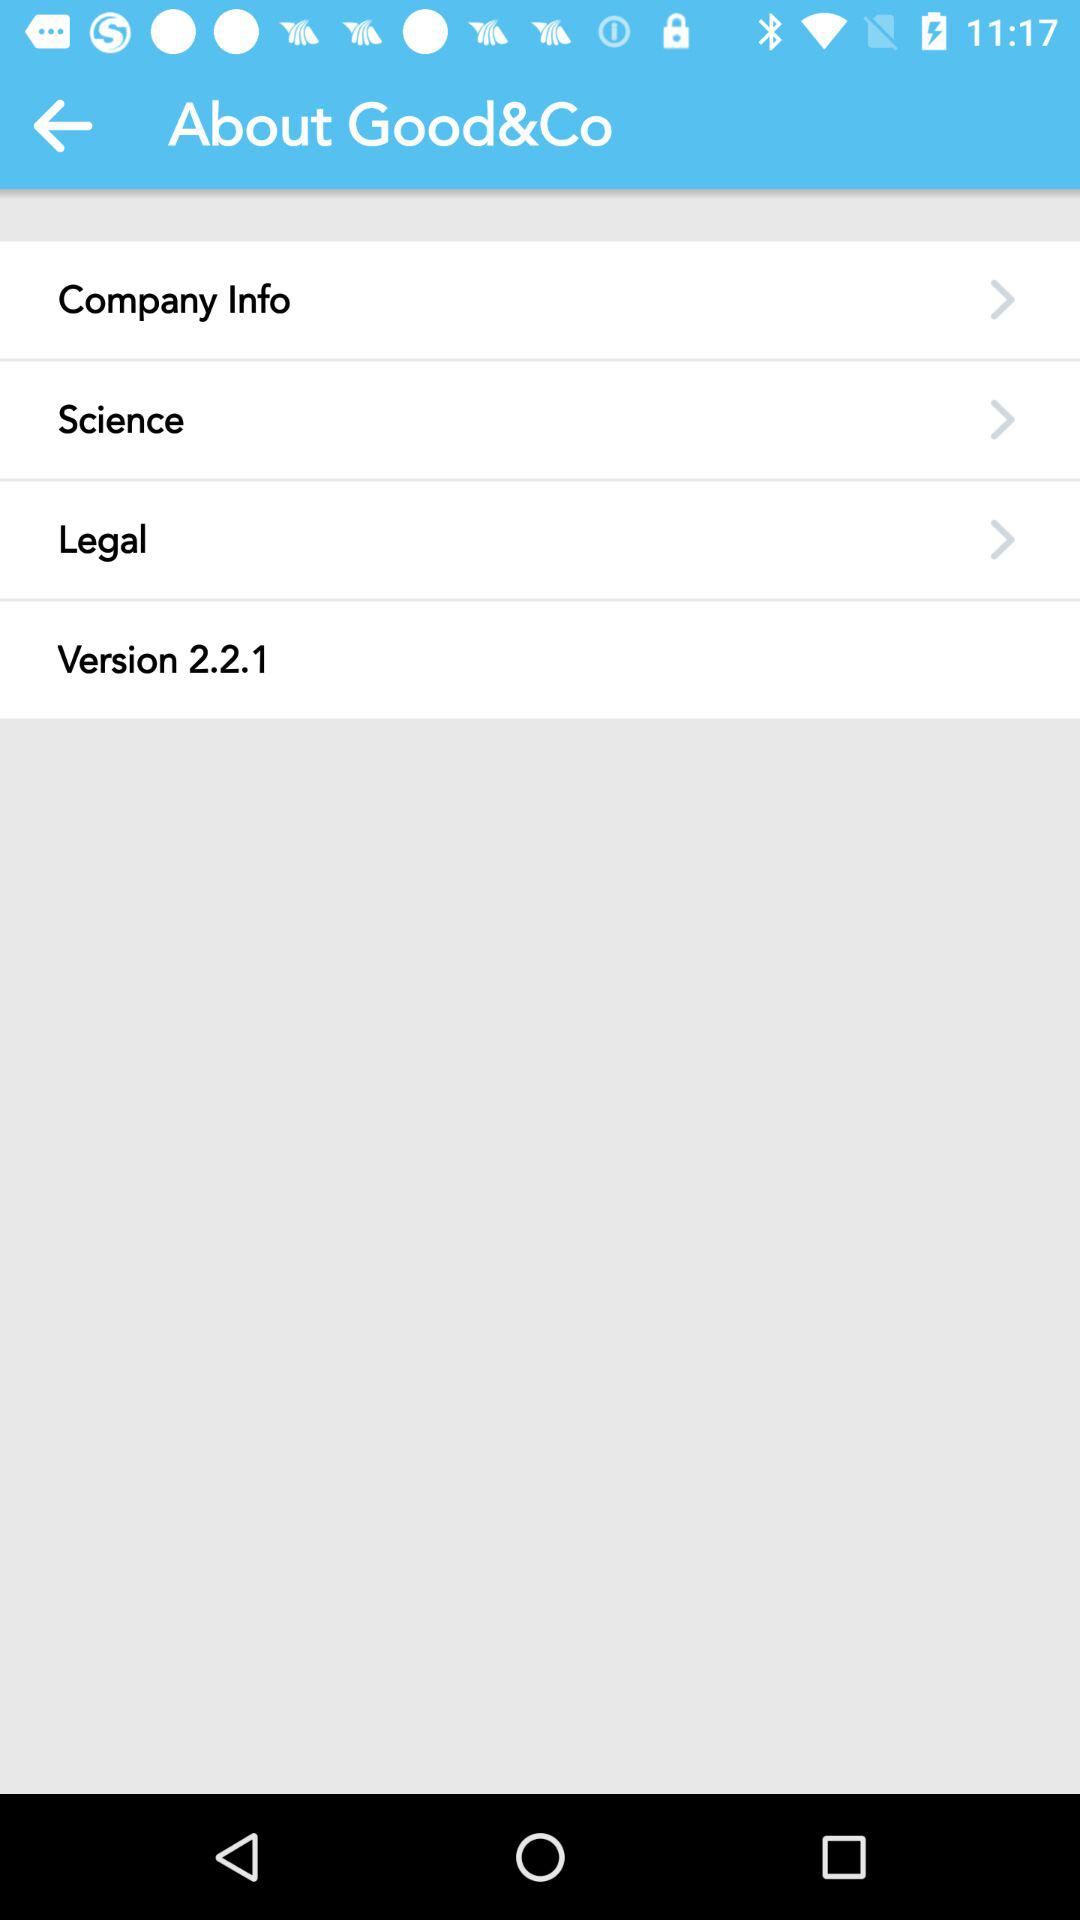What is the version? The version is 2.2.1. 